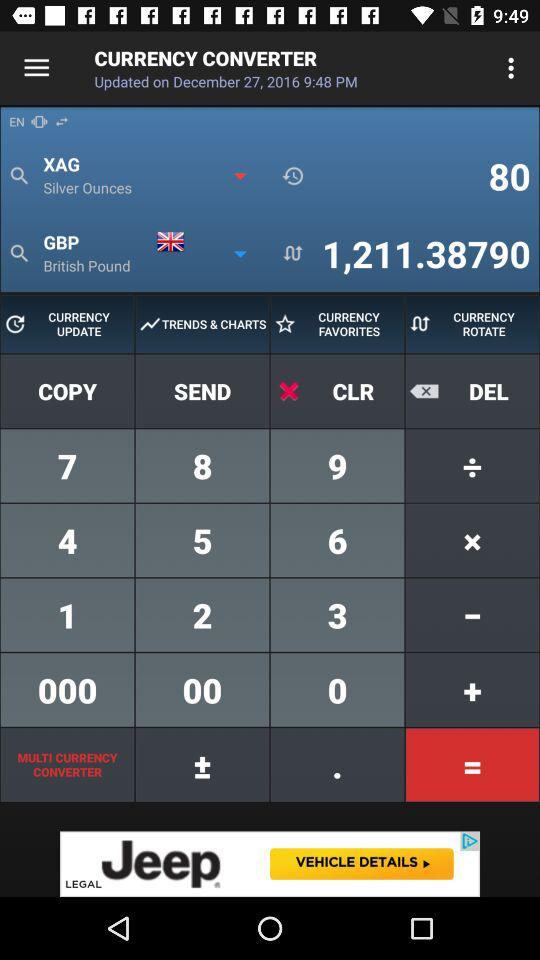What is the value of 80 silver ounces in British pounds? The value of 80 silver ounces in British pounds is 1,211.38790. 